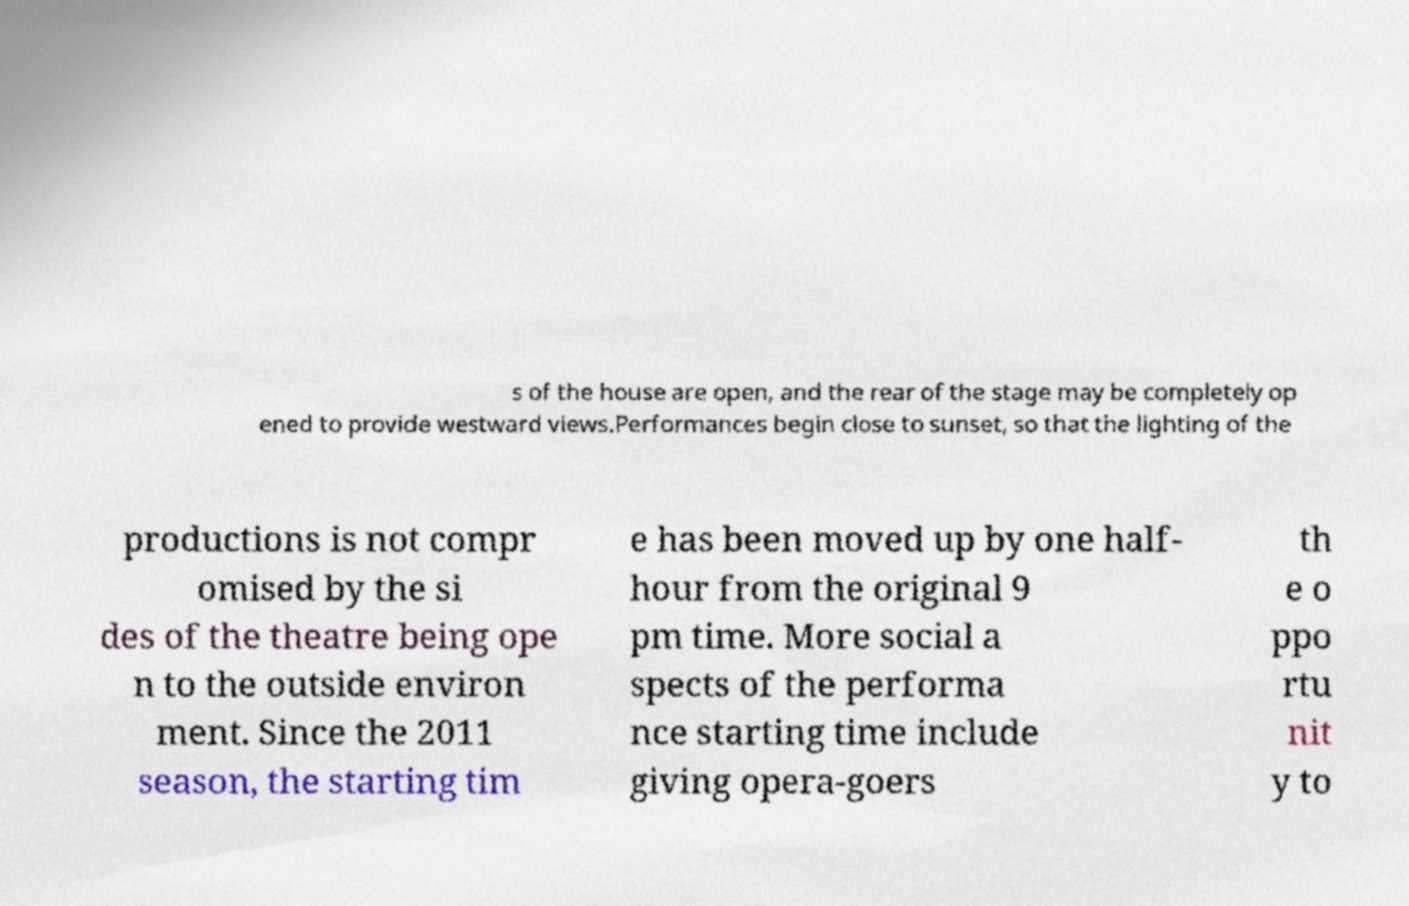Could you extract and type out the text from this image? s of the house are open, and the rear of the stage may be completely op ened to provide westward views.Performances begin close to sunset, so that the lighting of the productions is not compr omised by the si des of the theatre being ope n to the outside environ ment. Since the 2011 season, the starting tim e has been moved up by one half- hour from the original 9 pm time. More social a spects of the performa nce starting time include giving opera-goers th e o ppo rtu nit y to 